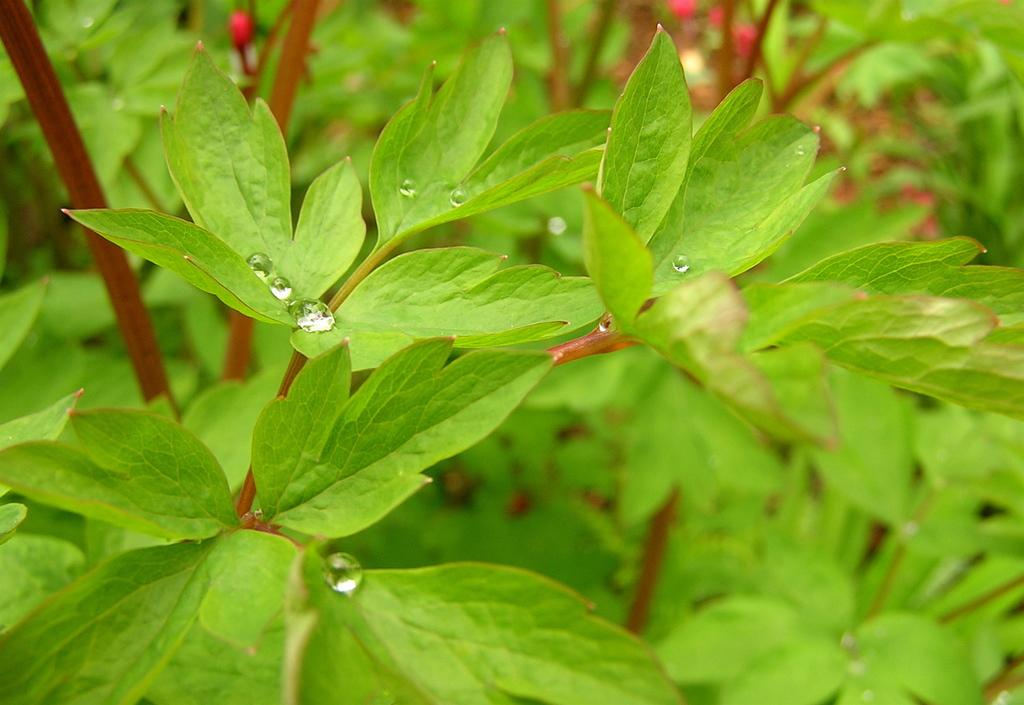What type of plants can be seen in the image? There are green color plants in the image. What can be observed on the leaves of the plants? There are water droplets on the leaves of the plants. What is the color of the stems in the image? There are red color stems in the image. What is the price of the hen in the image? There is no hen present in the image, so it is not possible to determine its price. 